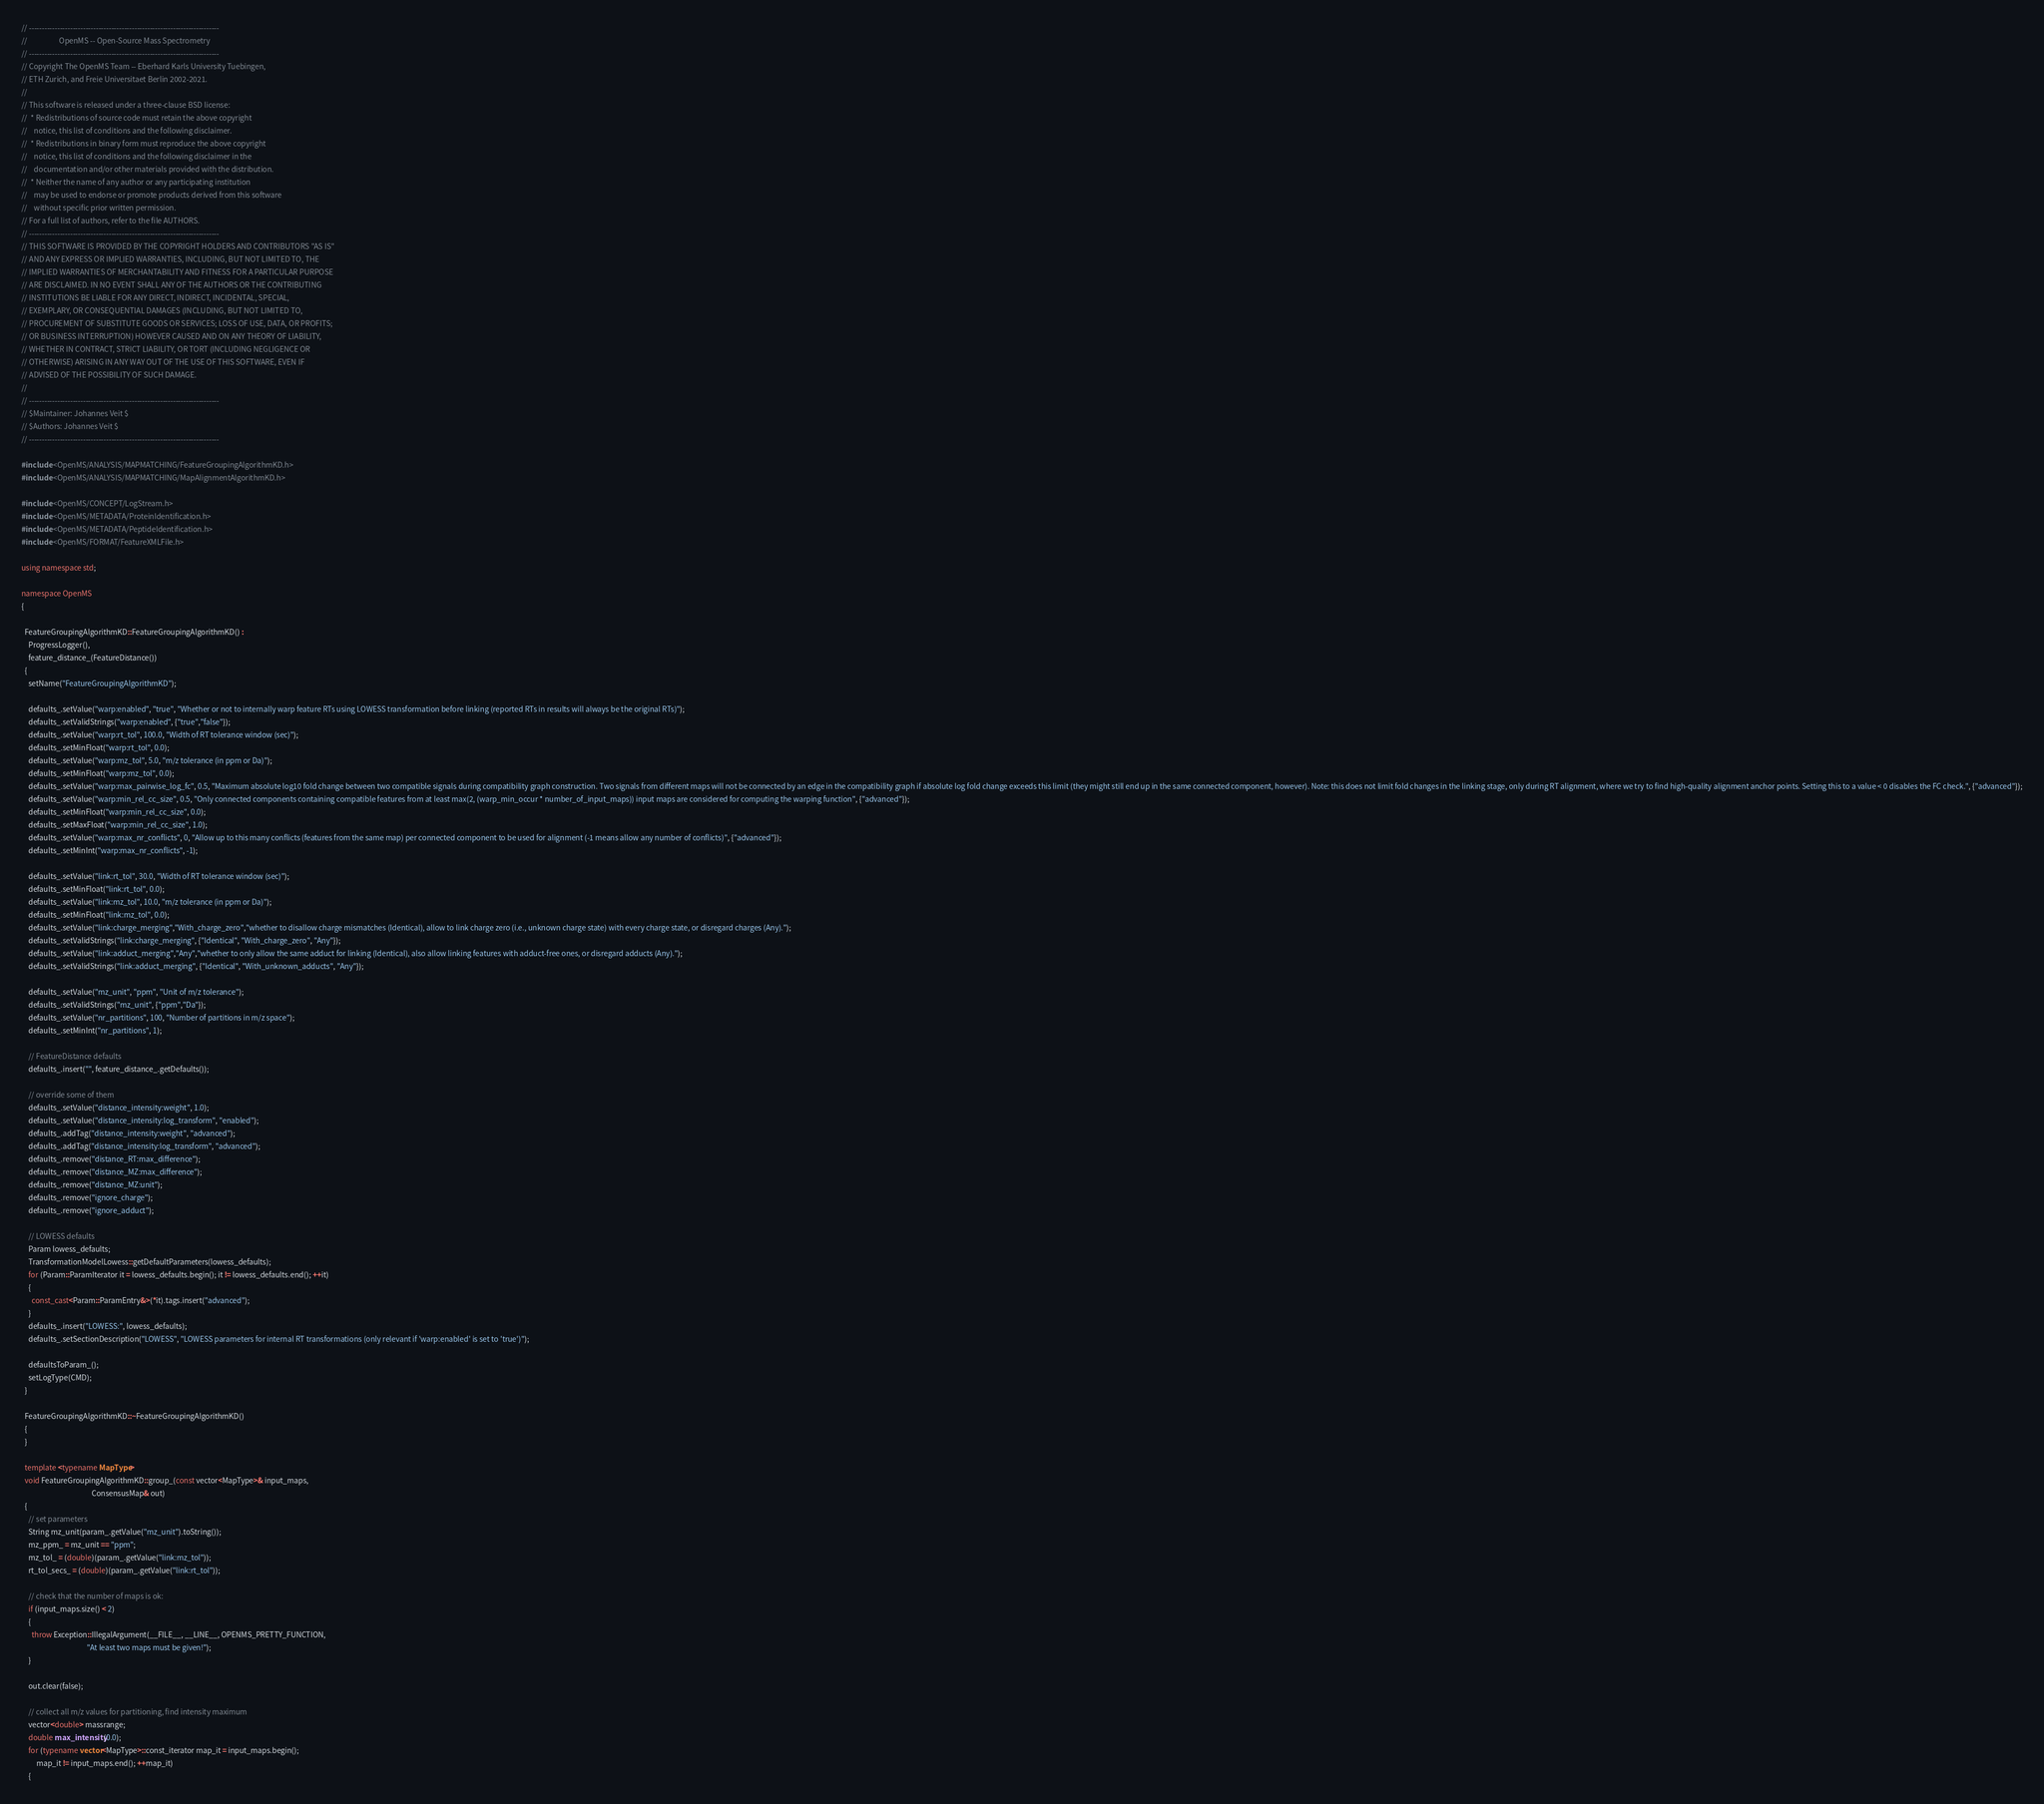<code> <loc_0><loc_0><loc_500><loc_500><_C++_>// --------------------------------------------------------------------------
//                   OpenMS -- Open-Source Mass Spectrometry
// --------------------------------------------------------------------------
// Copyright The OpenMS Team -- Eberhard Karls University Tuebingen,
// ETH Zurich, and Freie Universitaet Berlin 2002-2021.
//
// This software is released under a three-clause BSD license:
//  * Redistributions of source code must retain the above copyright
//    notice, this list of conditions and the following disclaimer.
//  * Redistributions in binary form must reproduce the above copyright
//    notice, this list of conditions and the following disclaimer in the
//    documentation and/or other materials provided with the distribution.
//  * Neither the name of any author or any participating institution
//    may be used to endorse or promote products derived from this software
//    without specific prior written permission.
// For a full list of authors, refer to the file AUTHORS.
// --------------------------------------------------------------------------
// THIS SOFTWARE IS PROVIDED BY THE COPYRIGHT HOLDERS AND CONTRIBUTORS "AS IS"
// AND ANY EXPRESS OR IMPLIED WARRANTIES, INCLUDING, BUT NOT LIMITED TO, THE
// IMPLIED WARRANTIES OF MERCHANTABILITY AND FITNESS FOR A PARTICULAR PURPOSE
// ARE DISCLAIMED. IN NO EVENT SHALL ANY OF THE AUTHORS OR THE CONTRIBUTING
// INSTITUTIONS BE LIABLE FOR ANY DIRECT, INDIRECT, INCIDENTAL, SPECIAL,
// EXEMPLARY, OR CONSEQUENTIAL DAMAGES (INCLUDING, BUT NOT LIMITED TO,
// PROCUREMENT OF SUBSTITUTE GOODS OR SERVICES; LOSS OF USE, DATA, OR PROFITS;
// OR BUSINESS INTERRUPTION) HOWEVER CAUSED AND ON ANY THEORY OF LIABILITY,
// WHETHER IN CONTRACT, STRICT LIABILITY, OR TORT (INCLUDING NEGLIGENCE OR
// OTHERWISE) ARISING IN ANY WAY OUT OF THE USE OF THIS SOFTWARE, EVEN IF
// ADVISED OF THE POSSIBILITY OF SUCH DAMAGE.
//
// --------------------------------------------------------------------------
// $Maintainer: Johannes Veit $
// $Authors: Johannes Veit $
// --------------------------------------------------------------------------

#include <OpenMS/ANALYSIS/MAPMATCHING/FeatureGroupingAlgorithmKD.h>
#include <OpenMS/ANALYSIS/MAPMATCHING/MapAlignmentAlgorithmKD.h>

#include <OpenMS/CONCEPT/LogStream.h>
#include <OpenMS/METADATA/ProteinIdentification.h>
#include <OpenMS/METADATA/PeptideIdentification.h>
#include <OpenMS/FORMAT/FeatureXMLFile.h>

using namespace std;

namespace OpenMS
{

  FeatureGroupingAlgorithmKD::FeatureGroupingAlgorithmKD() :
    ProgressLogger(),
    feature_distance_(FeatureDistance())
  {
    setName("FeatureGroupingAlgorithmKD");

    defaults_.setValue("warp:enabled", "true", "Whether or not to internally warp feature RTs using LOWESS transformation before linking (reported RTs in results will always be the original RTs)");
    defaults_.setValidStrings("warp:enabled", {"true","false"});
    defaults_.setValue("warp:rt_tol", 100.0, "Width of RT tolerance window (sec)");
    defaults_.setMinFloat("warp:rt_tol", 0.0);
    defaults_.setValue("warp:mz_tol", 5.0, "m/z tolerance (in ppm or Da)");
    defaults_.setMinFloat("warp:mz_tol", 0.0);
    defaults_.setValue("warp:max_pairwise_log_fc", 0.5, "Maximum absolute log10 fold change between two compatible signals during compatibility graph construction. Two signals from different maps will not be connected by an edge in the compatibility graph if absolute log fold change exceeds this limit (they might still end up in the same connected component, however). Note: this does not limit fold changes in the linking stage, only during RT alignment, where we try to find high-quality alignment anchor points. Setting this to a value < 0 disables the FC check.", {"advanced"});
    defaults_.setValue("warp:min_rel_cc_size", 0.5, "Only connected components containing compatible features from at least max(2, (warp_min_occur * number_of_input_maps)) input maps are considered for computing the warping function", {"advanced"});
    defaults_.setMinFloat("warp:min_rel_cc_size", 0.0);
    defaults_.setMaxFloat("warp:min_rel_cc_size", 1.0);
    defaults_.setValue("warp:max_nr_conflicts", 0, "Allow up to this many conflicts (features from the same map) per connected component to be used for alignment (-1 means allow any number of conflicts)", {"advanced"});
    defaults_.setMinInt("warp:max_nr_conflicts", -1);

    defaults_.setValue("link:rt_tol", 30.0, "Width of RT tolerance window (sec)");
    defaults_.setMinFloat("link:rt_tol", 0.0);
    defaults_.setValue("link:mz_tol", 10.0, "m/z tolerance (in ppm or Da)");
    defaults_.setMinFloat("link:mz_tol", 0.0);
    defaults_.setValue("link:charge_merging","With_charge_zero","whether to disallow charge mismatches (Identical), allow to link charge zero (i.e., unknown charge state) with every charge state, or disregard charges (Any).");
    defaults_.setValidStrings("link:charge_merging", {"Identical", "With_charge_zero", "Any"});
    defaults_.setValue("link:adduct_merging","Any","whether to only allow the same adduct for linking (Identical), also allow linking features with adduct-free ones, or disregard adducts (Any).");
    defaults_.setValidStrings("link:adduct_merging", {"Identical", "With_unknown_adducts", "Any"});

    defaults_.setValue("mz_unit", "ppm", "Unit of m/z tolerance");
    defaults_.setValidStrings("mz_unit", {"ppm","Da"});
    defaults_.setValue("nr_partitions", 100, "Number of partitions in m/z space");
    defaults_.setMinInt("nr_partitions", 1);

    // FeatureDistance defaults
    defaults_.insert("", feature_distance_.getDefaults());

    // override some of them
    defaults_.setValue("distance_intensity:weight", 1.0);
    defaults_.setValue("distance_intensity:log_transform", "enabled");
    defaults_.addTag("distance_intensity:weight", "advanced");
    defaults_.addTag("distance_intensity:log_transform", "advanced");
    defaults_.remove("distance_RT:max_difference");
    defaults_.remove("distance_MZ:max_difference");
    defaults_.remove("distance_MZ:unit");
    defaults_.remove("ignore_charge");
    defaults_.remove("ignore_adduct");      

    // LOWESS defaults
    Param lowess_defaults;
    TransformationModelLowess::getDefaultParameters(lowess_defaults);
    for (Param::ParamIterator it = lowess_defaults.begin(); it != lowess_defaults.end(); ++it)
    {
      const_cast<Param::ParamEntry&>(*it).tags.insert("advanced");
    }
    defaults_.insert("LOWESS:", lowess_defaults);
    defaults_.setSectionDescription("LOWESS", "LOWESS parameters for internal RT transformations (only relevant if 'warp:enabled' is set to 'true')");

    defaultsToParam_();
    setLogType(CMD);
  }

  FeatureGroupingAlgorithmKD::~FeatureGroupingAlgorithmKD()
  {
  }

  template <typename MapType>
  void FeatureGroupingAlgorithmKD::group_(const vector<MapType>& input_maps,
                                          ConsensusMap& out)
  {
    // set parameters
    String mz_unit(param_.getValue("mz_unit").toString());
    mz_ppm_ = mz_unit == "ppm";
    mz_tol_ = (double)(param_.getValue("link:mz_tol"));
    rt_tol_secs_ = (double)(param_.getValue("link:rt_tol"));

    // check that the number of maps is ok:
    if (input_maps.size() < 2)
    {
      throw Exception::IllegalArgument(__FILE__, __LINE__, OPENMS_PRETTY_FUNCTION,
                                       "At least two maps must be given!");
    }

    out.clear(false);

    // collect all m/z values for partitioning, find intensity maximum
    vector<double> massrange;
    double max_intensity(0.0);
    for (typename vector<MapType>::const_iterator map_it = input_maps.begin();
         map_it != input_maps.end(); ++map_it)
    {</code> 